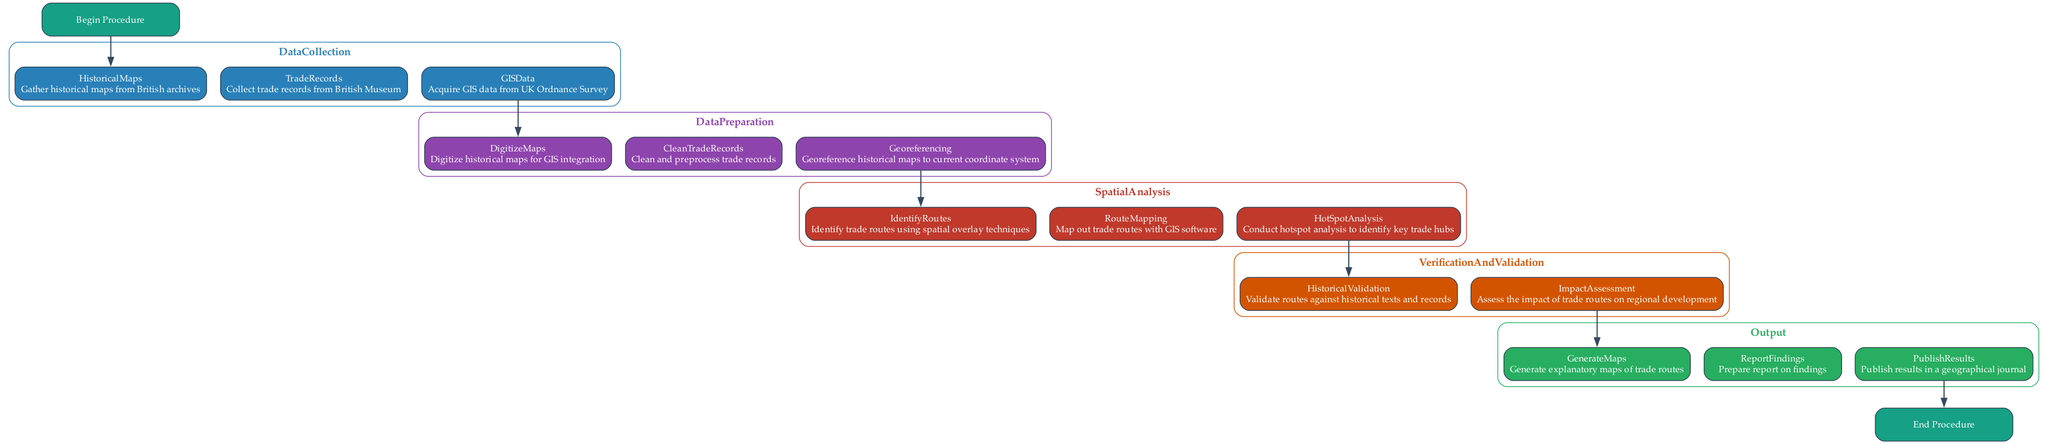What is the first step in the procedure? The first step in the procedure is indicated by the "Start" node, which connects to "DataCollection". This shows that the procedure begins with gathering data.
Answer: DataCollection How many main process nodes are there in the diagram? The main process nodes are represented in clusters named DataCollection, DataPreparation, SpatialAnalysis, VerificationAndValidation, and Output. There are five clusters in total.
Answer: Five What is the last node before the "End" node? The last process before the "End" is indicated by the output of the Output cluster. The final step in this cluster is "PublishResults", which connects directly to the "End" node.
Answer: PublishResults Which process follows "DataPreparation"? The flow of the diagram shows that "DataPreparation" is followed by "SpatialAnalysis". This is determined by the direct link from the last step of "DataPreparation" to the first step of "SpatialAnalysis".
Answer: SpatialAnalysis What key validation steps are included in the Verification and Validation phase? Within the Verification and Validation cluster, two main validation steps are listed: "HistoricalValidation" and "ImpactAssessment". Both steps are necessary to ensure the findings are accurate and relevant.
Answer: HistoricalValidation and ImpactAssessment How does "IdentifyRoutes" connect to the rest of the diagram? "IdentifyRoutes" is placed within the "SpatialAnalysis" section, and it follows "Georeferencing", so it is the second step in that cluster. Its connection shows it relates to both data collected and maps prepared before its analysis.
Answer: Georeferencing What cluster comes directly after DataCollection? The cluster that comes directly after "DataCollection" is "DataPreparation". The diagram structure indicates a sequential flow from gathering data to preparing it for further analysis.
Answer: DataPreparation How many steps are in the Output cluster? The Output cluster contains three specific steps listed: "GenerateMaps", "ReportFindings", and "PublishResults", indicating that the final outcomes include mapping, reporting, and publication.
Answer: Three 